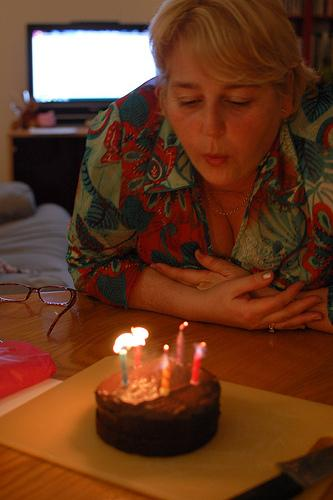List all of the different cake-related objects in this image and their respective sizes. 5. Small round cake, Width: 227, Height: 227 Determine the sentiment of the image. The sentiment of the image is joyful, as it captures a celebratory moment during a birthday party. How many candles are mentioned in the objects, and what are some of their colors? Several candles are mentioned, with at least two colors - blue and orange. What activities are taking place in the image, and who is the principal subject? The main subject is a woman in a green and red blouse blowing out candles on a birthday cake. What color are the lit candles? Blue and orange What type of cake is present in the image? Chocolate birthday cake What is the color of the blouse the woman is wearing? Green and red Which action is the woman performing in the image? (a) eating the cake (b) cutting the cake (c) blowing out candles (d) putting on glasses (c) blowing out candles Is the knife on the cutting board red? There is a black knife on a cutting board, not a red one. The instruction is misleading because it gives the wrong color for the knife on the cutting board. Is the man wearing a green and red blouse in the image? There is a woman in a green and red blouse, not a man. The instruction is misleading because it gives the wrong gender for the person in the blouse. Which object on the cutting board is most likely to be used to cut the cake in the image? A black knife Describe the woman's hairstyle in the image. The woman has short blonde hair. Does the woman have any accessories on in the image? Yes, she is wearing a necklace, a ring, and earrings. What unique features can be observed on the woman's shirt? It is a colorful shirt with a green and red pattern. Describe the emotions displayed by the woman in the image. The woman appears happy and excited while blowing out the candles. Does the woman have long blonde hair? The woman has short blonde hair, not long. The instruction is misleading because it gives the wrong hair length for the woman in the image. What appliance can be observed in the background of the image? A wide-screen TV What is the position of the glasses in relation to the cake? The glasses are on a table, beside the cake. Can you find the blue birthday cake in the image? There is a chocolate birthday cake, not a blue one. The instruction is misleading because it gives the wrong color for the cake in the image. What is resting on the gray couch? There is no identifiable item resting on the gray couch. Analyze the picture and tell me what type of event might be occurring. A birthday party or celebration Can you find the green couch in the image? There is a gray couch, not a green one. The instruction is misleading because it gives the wrong color for the couch in the image. List the possible gifts near the cake in the image. Red wrapped birthday gift Is there a dog wearing reading glasses on the table? The image has a pair of reading glasses on the table, but there is no dog. The instruction is misleading because it adds an unrelated object (dog) that is not present in the image. Write a brief caption capturing the scene in the image. A joyful woman blowing out candles on a chocolate birthday cake. Based on the image, what is placed on the table beside the cake? Reading glasses How many candles have been blown out already? Three Identify the object that is displayed close to the woman's face. A few lit candles on a chocolate birthday cake. Create a detailed description of the image content. A happy woman with short blonde hair is blowing out candles on a small chocolate birthday cake placed on a table. She is wearing a green and red blouse, a necklace, earrings, and a ring. Reading glasses are also on the table. In the background, there is a wide-screen TV and a gray couch. What is the woman in the image holding in her hands? The woman's hands are free, and they are not holding anything. 